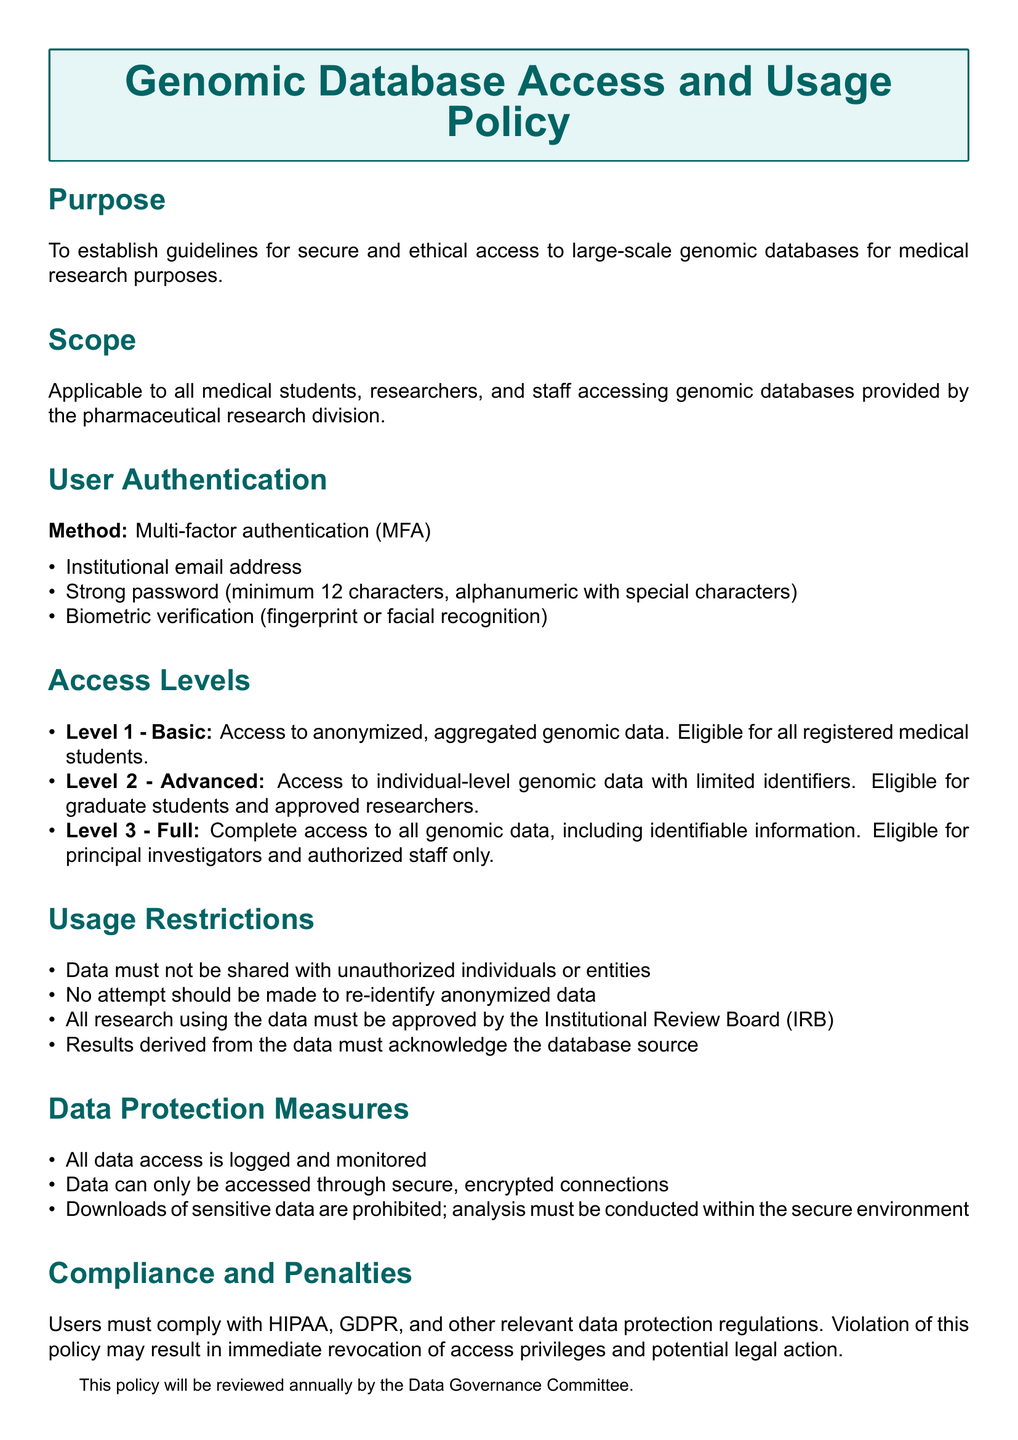What authentication method is used? The document specifies that multi-factor authentication (MFA) is the authentication method used for accessing genomic databases.
Answer: Multi-factor authentication (MFA) What is the minimum password length? The policy states that the password must be a minimum of 12 characters long.
Answer: 12 characters Who is eligible for Level 3 access? The document outlines that only principal investigators and authorized staff are eligible for Level 3 access to genomic data.
Answer: Principal investigators and authorized staff What are users prohibited from doing with anonymized data? The usage restrictions indicate that no attempt should be made to re-identify anonymized data.
Answer: Re-identify anonymized data How often will the policy be reviewed? The document mentions that the policy will be reviewed annually by the Data Governance Committee.
Answer: Annually 